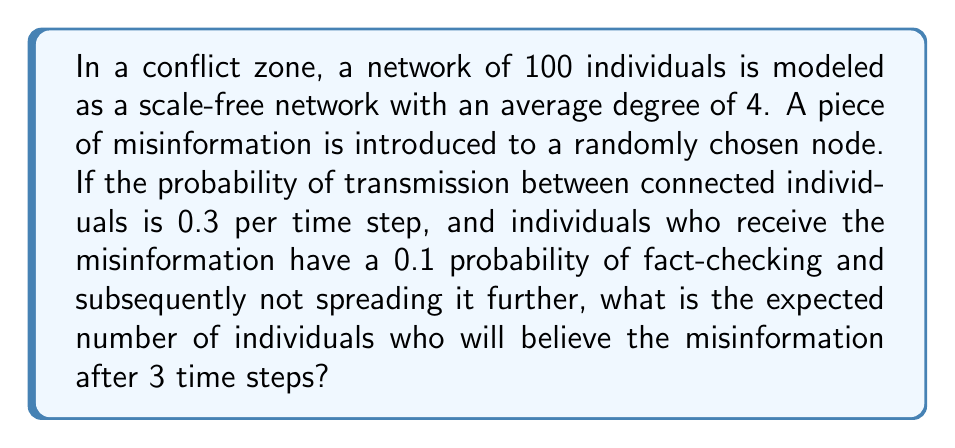Provide a solution to this math problem. Let's approach this step-by-step:

1) First, we need to understand the network structure:
   - Scale-free network with 100 nodes
   - Average degree of 4

2) The spreading process:
   - Initial infection: 1 node
   - Transmission probability: $p_t = 0.3$
   - Fact-checking probability: $p_f = 0.1$
   - Effective transmission probability: $p_e = p_t(1-p_f) = 0.3 * 0.9 = 0.27$

3) We can model this spread using the SIS (Susceptible-Infected-Susceptible) model adapted for misinformation spread.

4) In a scale-free network, the spread is typically faster than in random networks. We can approximate the spread using the basic reproductive number $R_0$:

   $R_0 \approx \frac{\langle k^2 \rangle}{\langle k \rangle} p_e$

   where $\langle k \rangle$ is the average degree and $\langle k^2 \rangle$ is the second moment of the degree distribution.

5) For a scale-free network, $\langle k^2 \rangle$ is typically much larger than $\langle k \rangle$. Let's estimate $\langle k^2 \rangle \approx 30$ (this is an approximation based on typical scale-free network properties).

6) Calculate $R_0$:
   $R_0 \approx \frac{30}{4} * 0.27 \approx 2.025$

7) The number of infected nodes after $t$ time steps can be approximated by:
   $I(t) \approx I(0) * R_0^t$

8) After 3 time steps:
   $I(3) \approx 1 * 2.025^3 \approx 8.30$

Therefore, we expect approximately 8 individuals to believe the misinformation after 3 time steps.
Answer: 8 